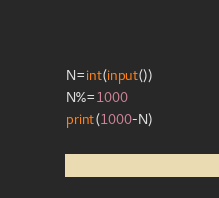Convert code to text. <code><loc_0><loc_0><loc_500><loc_500><_Python_>N=int(input())
N%=1000
print(1000-N)</code> 